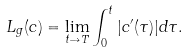<formula> <loc_0><loc_0><loc_500><loc_500>L _ { g } ( c ) = \lim _ { t \to T } \int _ { 0 } ^ { t } | c ^ { \prime } ( \tau ) | d \tau .</formula> 